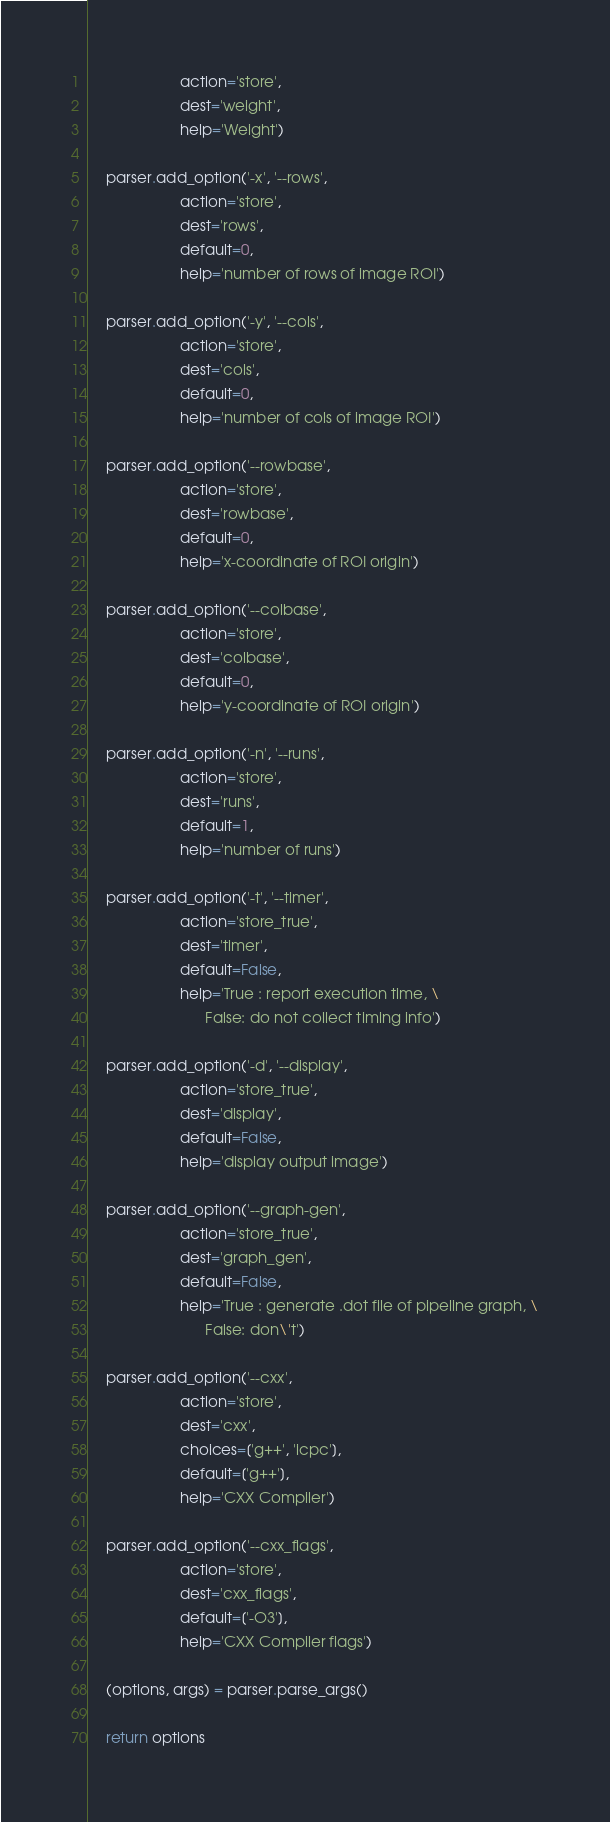Convert code to text. <code><loc_0><loc_0><loc_500><loc_500><_Python_>                      action='store',
                      dest='weight',
                      help='Weight')

    parser.add_option('-x', '--rows',
                      action='store',
                      dest='rows',
                      default=0,
                      help='number of rows of image ROI')

    parser.add_option('-y', '--cols',
                      action='store',
                      dest='cols',
                      default=0,
                      help='number of cols of image ROI')

    parser.add_option('--rowbase',
                      action='store',
                      dest='rowbase',
                      default=0,
                      help='x-coordinate of ROI origin')

    parser.add_option('--colbase',
                      action='store',
                      dest='colbase',
                      default=0,
                      help='y-coordinate of ROI origin')

    parser.add_option('-n', '--runs',
                      action='store',
                      dest='runs',
                      default=1,
                      help='number of runs')

    parser.add_option('-t', '--timer',
                      action='store_true',
                      dest='timer',
                      default=False,
                      help='True : report execution time, \
                            False: do not collect timing info')

    parser.add_option('-d', '--display',
                      action='store_true',
                      dest='display',
                      default=False,
                      help='display output image')

    parser.add_option('--graph-gen',
                      action='store_true',
                      dest='graph_gen',
                      default=False,
                      help='True : generate .dot file of pipeline graph, \
                            False: don\'t')

    parser.add_option('--cxx',
                      action='store',
                      dest='cxx',
                      choices=['g++', 'icpc'],
                      default=['g++'],
                      help='CXX Compiler')

    parser.add_option('--cxx_flags',
                      action='store',
                      dest='cxx_flags',
                      default=['-O3'],
                      help='CXX Compiler flags')

    (options, args) = parser.parse_args()

    return options
</code> 